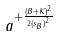<formula> <loc_0><loc_0><loc_500><loc_500>a ^ { + \frac { ( B + K ) ^ { 2 } } { 2 { ( s _ { B } ) } ^ { 2 } } }</formula> 